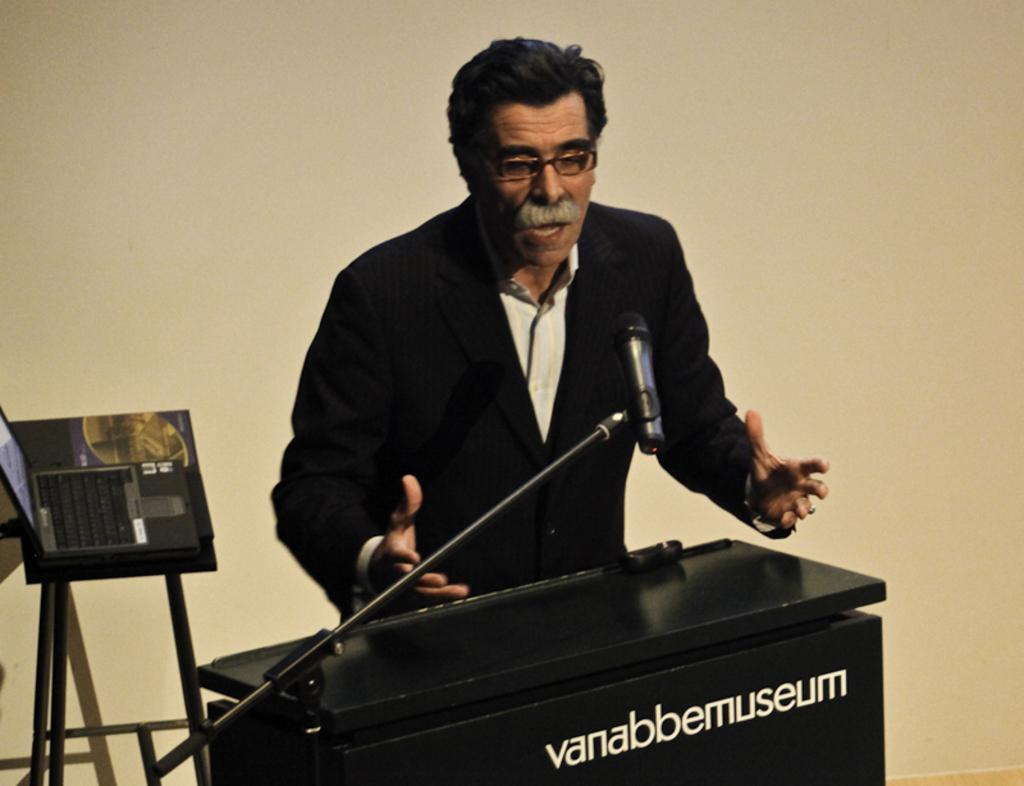Describe this image in one or two sentences. In this image I can see a person wearing shirt and black colored blazer is standing in front of a black colored box and I can see a microphone in front of him. I can see a stool and on the stool I can see a black colored laptop. In the background I can see the cream colored wall. 